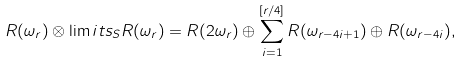<formula> <loc_0><loc_0><loc_500><loc_500>R ( \omega _ { r } ) \otimes \lim i t s _ { S } R ( \omega _ { r } ) = R ( 2 \omega _ { r } ) \oplus \sum _ { i = 1 } ^ { [ r / 4 ] } R ( \omega _ { r - 4 i + 1 } ) \oplus R ( \omega _ { r - 4 i } ) ,</formula> 